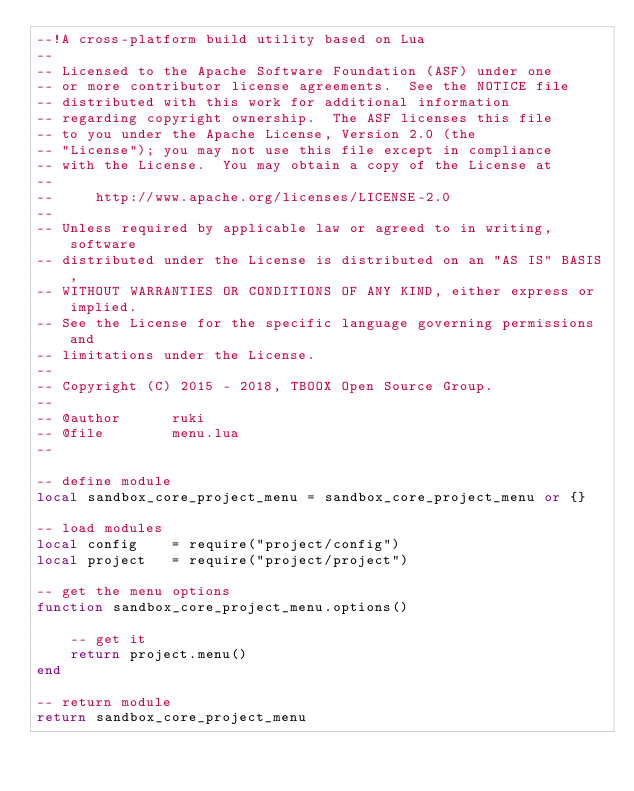Convert code to text. <code><loc_0><loc_0><loc_500><loc_500><_Lua_>--!A cross-platform build utility based on Lua
--
-- Licensed to the Apache Software Foundation (ASF) under one
-- or more contributor license agreements.  See the NOTICE file
-- distributed with this work for additional information
-- regarding copyright ownership.  The ASF licenses this file
-- to you under the Apache License, Version 2.0 (the
-- "License"); you may not use this file except in compliance
-- with the License.  You may obtain a copy of the License at
--
--     http://www.apache.org/licenses/LICENSE-2.0
--
-- Unless required by applicable law or agreed to in writing, software
-- distributed under the License is distributed on an "AS IS" BASIS,
-- WITHOUT WARRANTIES OR CONDITIONS OF ANY KIND, either express or implied.
-- See the License for the specific language governing permissions and
-- limitations under the License.
-- 
-- Copyright (C) 2015 - 2018, TBOOX Open Source Group.
--
-- @author      ruki
-- @file        menu.lua
--

-- define module
local sandbox_core_project_menu = sandbox_core_project_menu or {}

-- load modules
local config    = require("project/config")
local project   = require("project/project")

-- get the menu options
function sandbox_core_project_menu.options()

    -- get it 
    return project.menu()
end

-- return module
return sandbox_core_project_menu
</code> 